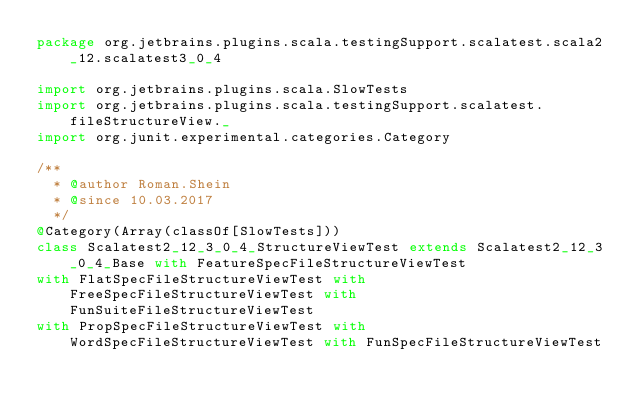Convert code to text. <code><loc_0><loc_0><loc_500><loc_500><_Scala_>package org.jetbrains.plugins.scala.testingSupport.scalatest.scala2_12.scalatest3_0_4

import org.jetbrains.plugins.scala.SlowTests
import org.jetbrains.plugins.scala.testingSupport.scalatest.fileStructureView._
import org.junit.experimental.categories.Category

/**
  * @author Roman.Shein
  * @since 10.03.2017
  */
@Category(Array(classOf[SlowTests]))
class Scalatest2_12_3_0_4_StructureViewTest extends Scalatest2_12_3_0_4_Base with FeatureSpecFileStructureViewTest
with FlatSpecFileStructureViewTest with FreeSpecFileStructureViewTest with FunSuiteFileStructureViewTest
with PropSpecFileStructureViewTest with WordSpecFileStructureViewTest with FunSpecFileStructureViewTest
</code> 